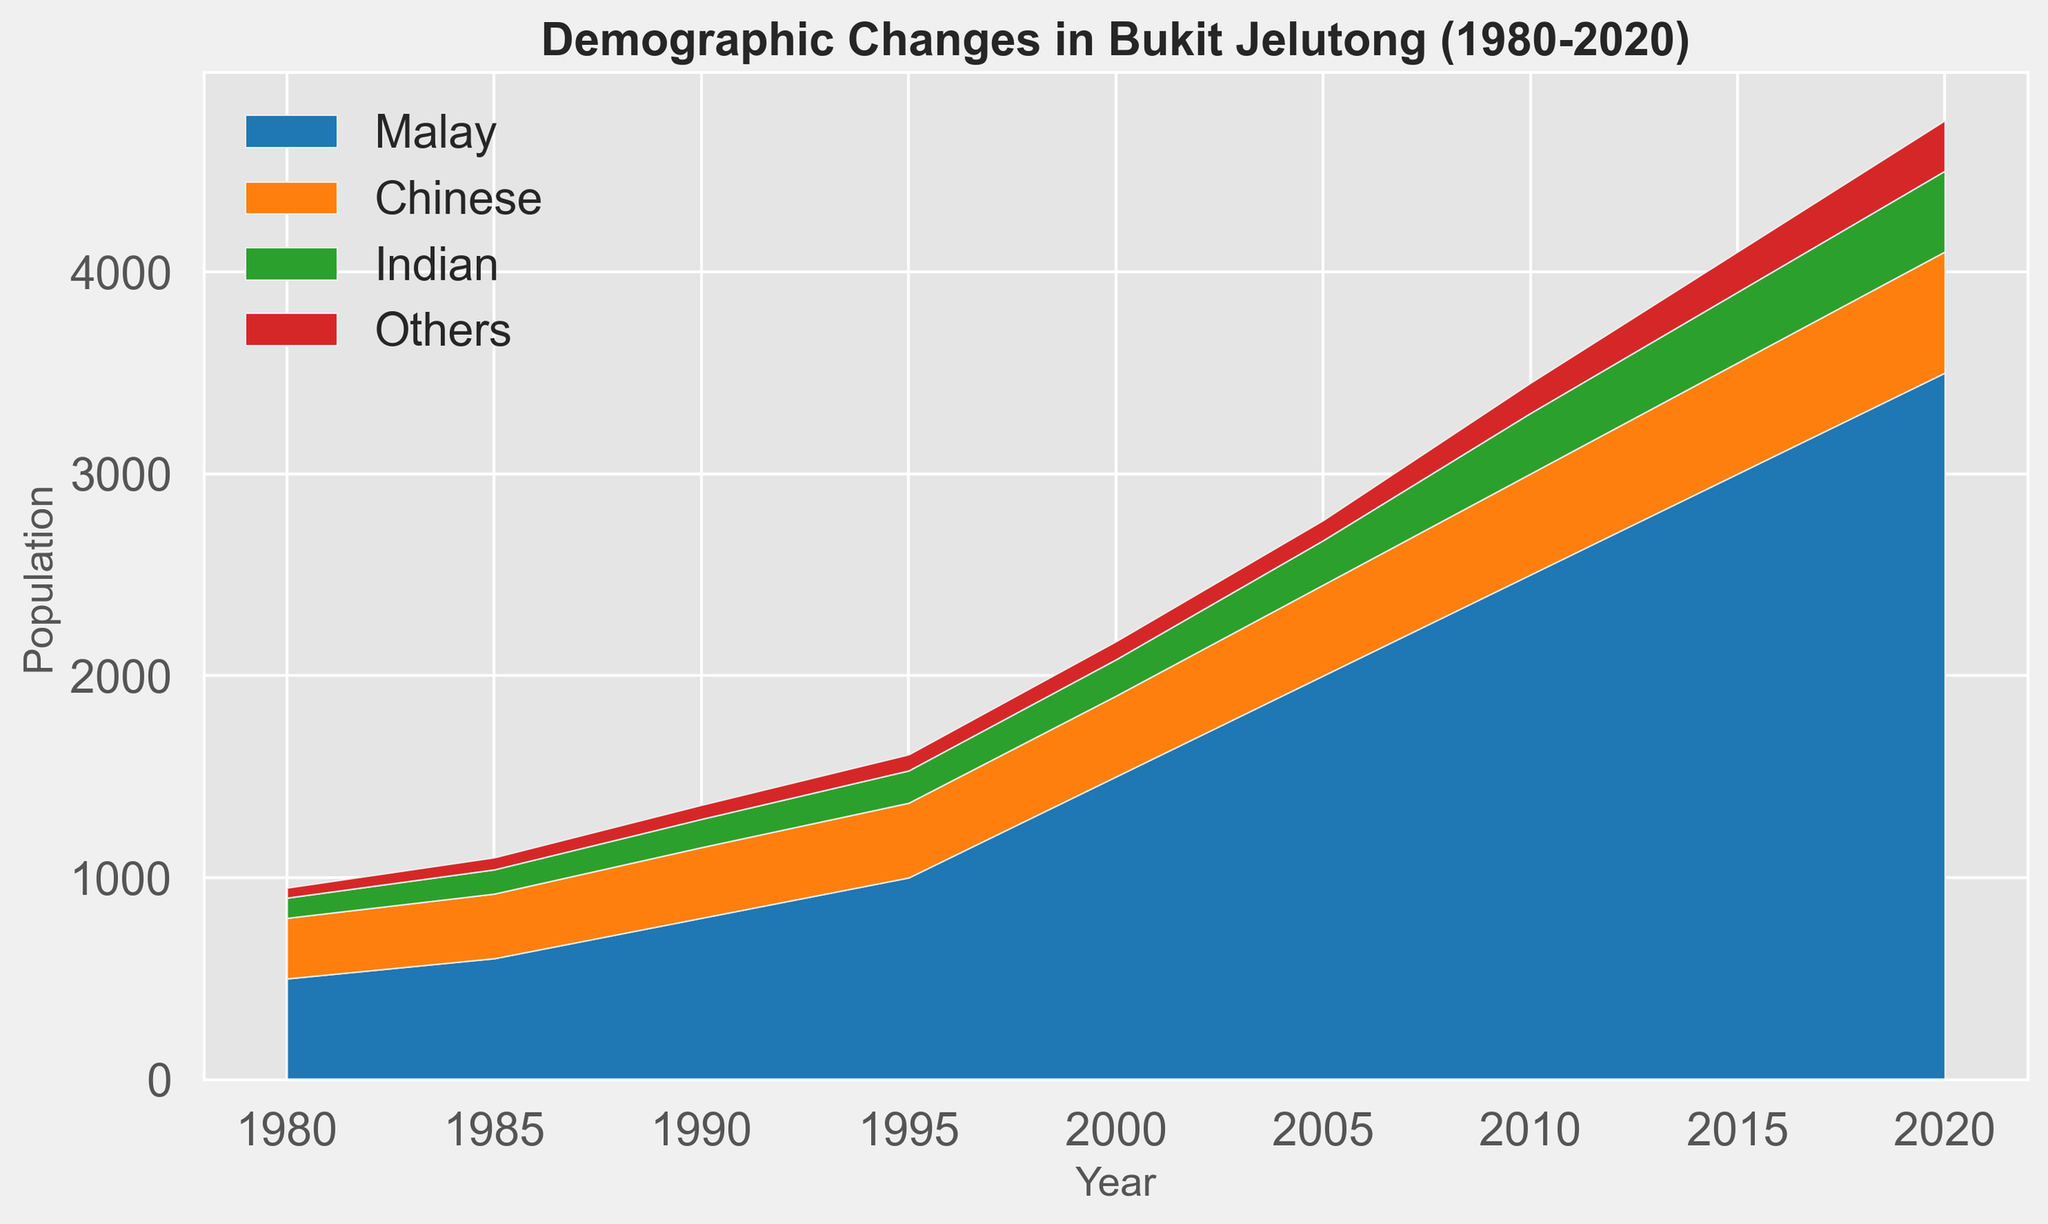What was the total population of Bukit Jelutong in 1980? To find the total population in 1980, sum the populations of all ethnic groups: Malay (500), Chinese (300), Indian (100), and Others (50). So, 500 + 300 + 100 + 50 = 950.
Answer: 950 Which ethnic group had the highest population growth between 1980 and 2020? Subtract the 1980 population from the 2020 population for each group:
- Malay: 3500 - 500 = 3000
- Chinese: 600 - 300 = 300
- Indian: 400 - 100 = 300
- Others: 250 - 50 = 200
Malay had the highest growth with 3000.
Answer: Malay Between which consecutive years did the Malay population see the largest increase? Calculate the differences for each year interval:
- 1980 to 1985: 600 - 500 = 100
- 1985 to 1990: 800 - 600 = 200
- 1990 to 1995: 1000 - 800 = 200
- 1995 to 2000: 1500 - 1000 = 500
- 2000 to 2005: 2000 - 1500 = 500
- 2005 to 2010: 2500 - 2000 = 500
- 2010 to 2015: 3000 - 2500 = 500
- 2015 to 2020: 3500 - 3000 = 500
Largest increase is 500 seen between 1995 to 2000, 2000 to 2005, 2005 to 2010, 2010 to 2015, and 2015 to 2020.
Answer: 1995 to 2000 By how much did the combined population of all ethnic groups change from 2000 to 2010? Calculate the total population for 2000 and 2010:
- 2000: 1500 (Malay) + 400 (Chinese) + 180 (Indian) + 90 (Others) = 2170
- 2010: 2500 (Malay) + 500 (Chinese) + 300 (Indian) + 150 (Others) = 3450
The change is 3450 - 2170 = 1280.
Answer: 1280 What was the total population of non-Malay ethnic groups in 2020? Sum the populations for the Chinese, Indian, and Others in 2020:
- Chinese: 600
- Indian: 400
- Others: 250
So, 600 + 400 + 250 = 1250.
Answer: 1250 